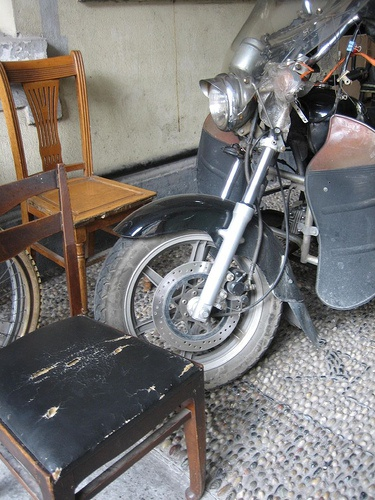Describe the objects in this image and their specific colors. I can see motorcycle in lightgray, gray, darkgray, and black tones, chair in lightgray, black, gray, and maroon tones, and chair in lightgray, brown, maroon, and gray tones in this image. 